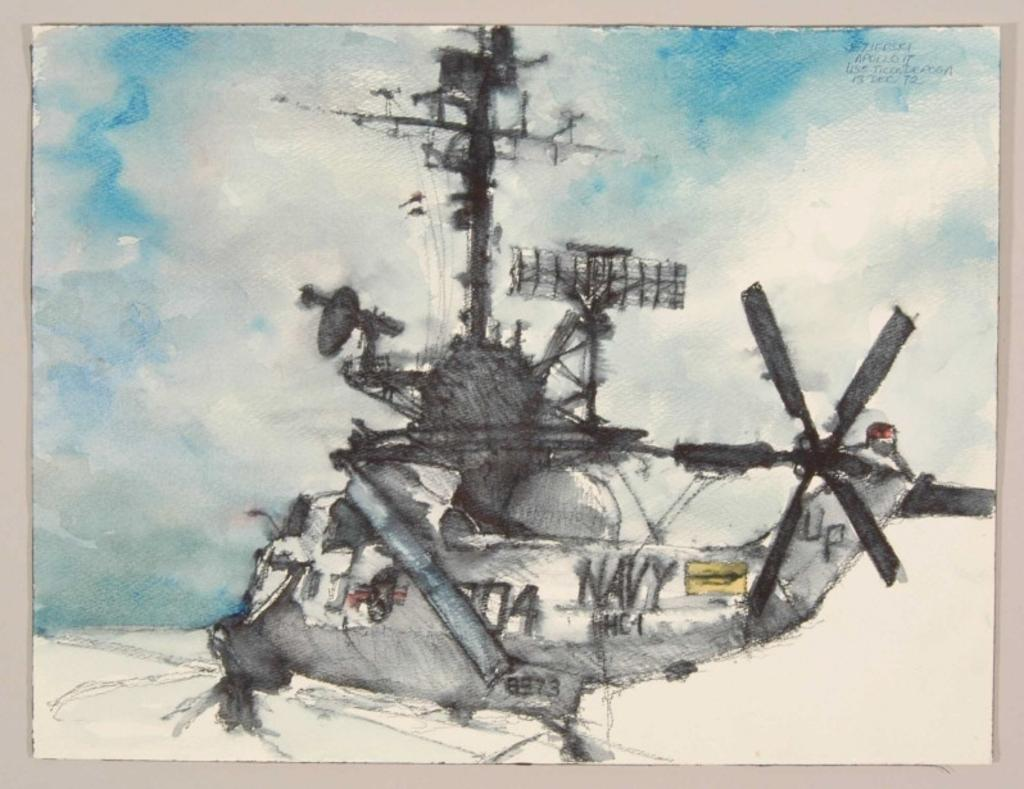<image>
Present a compact description of the photo's key features. An watercolor painting of a Navy helicopter against a cloudy sky. 